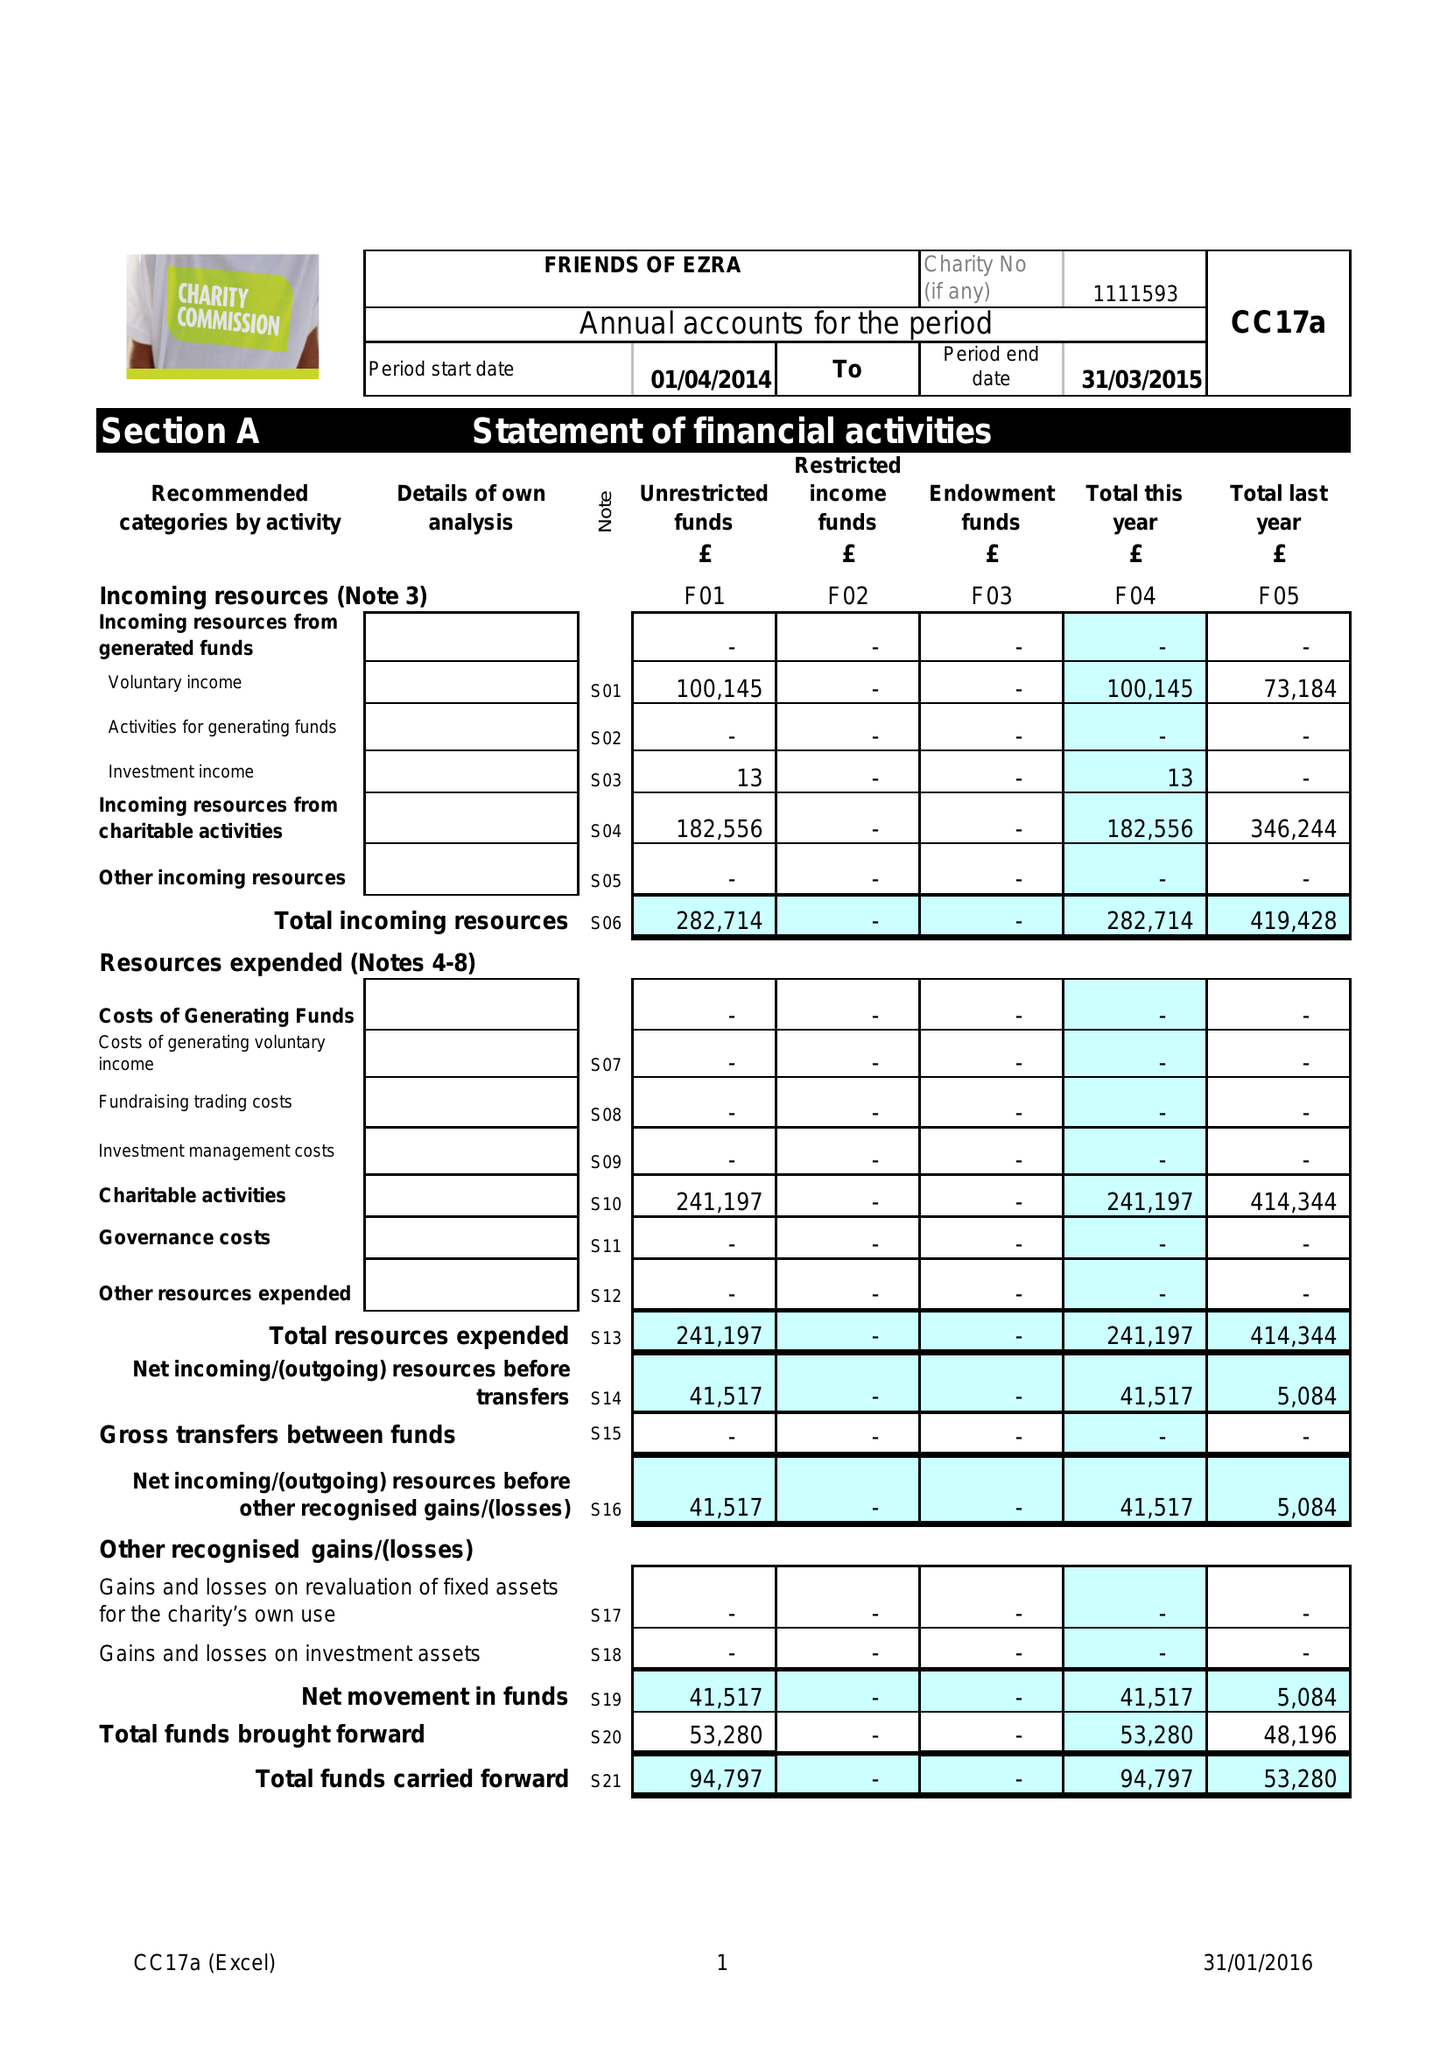What is the value for the report_date?
Answer the question using a single word or phrase. 2015-03-31 